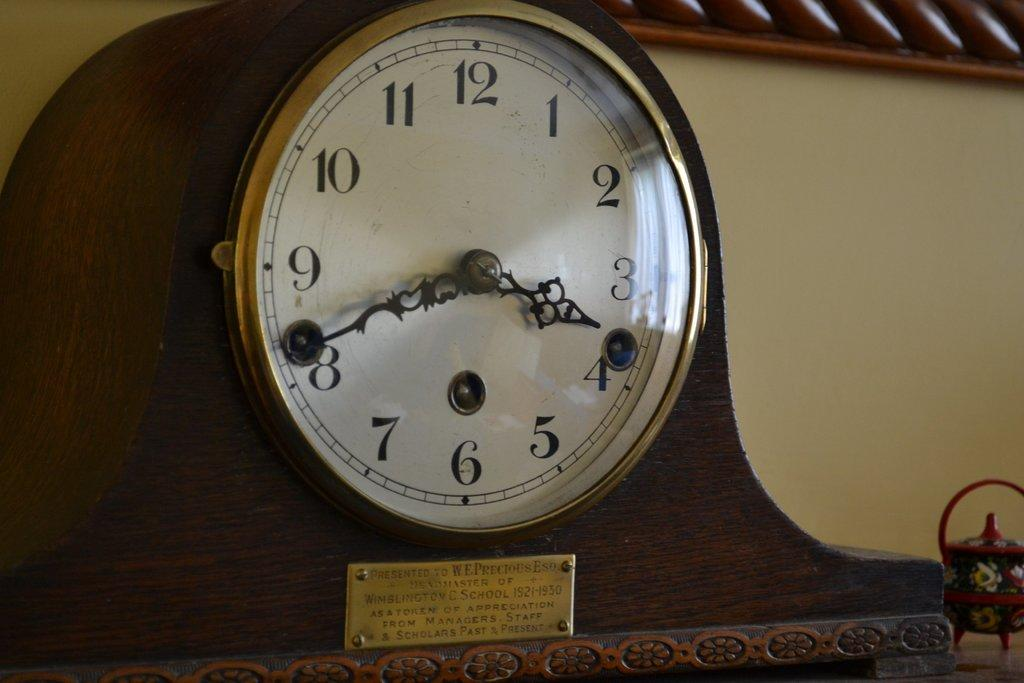<image>
Provide a brief description of the given image. A clock's plaque states it was presented to a W. E. Precious, Esq. 